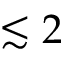<formula> <loc_0><loc_0><loc_500><loc_500>\lesssim 2</formula> 